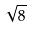Convert formula to latex. <formula><loc_0><loc_0><loc_500><loc_500>\sqrt { 8 }</formula> 